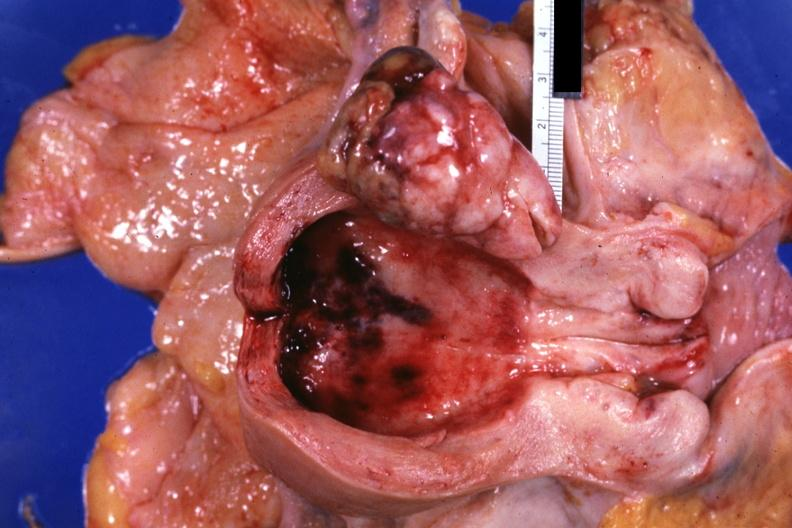what is present?
Answer the question using a single word or phrase. Mixed mesodermal tumor 